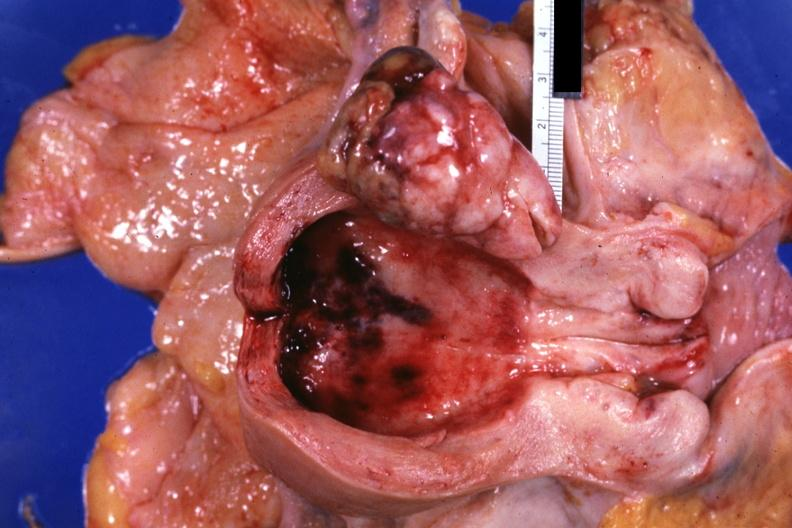what is present?
Answer the question using a single word or phrase. Mixed mesodermal tumor 